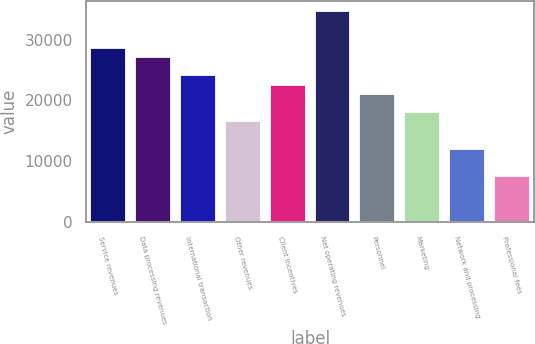<chart> <loc_0><loc_0><loc_500><loc_500><bar_chart><fcel>Service revenues<fcel>Data processing revenues<fcel>International transaction<fcel>Other revenues<fcel>Client incentives<fcel>Net operating revenues<fcel>Personnel<fcel>Marketing<fcel>Network and processing<fcel>Professional fees<nl><fcel>28654<fcel>27146<fcel>24130<fcel>16590<fcel>22622<fcel>34686<fcel>21114<fcel>18098<fcel>12066<fcel>7542<nl></chart> 